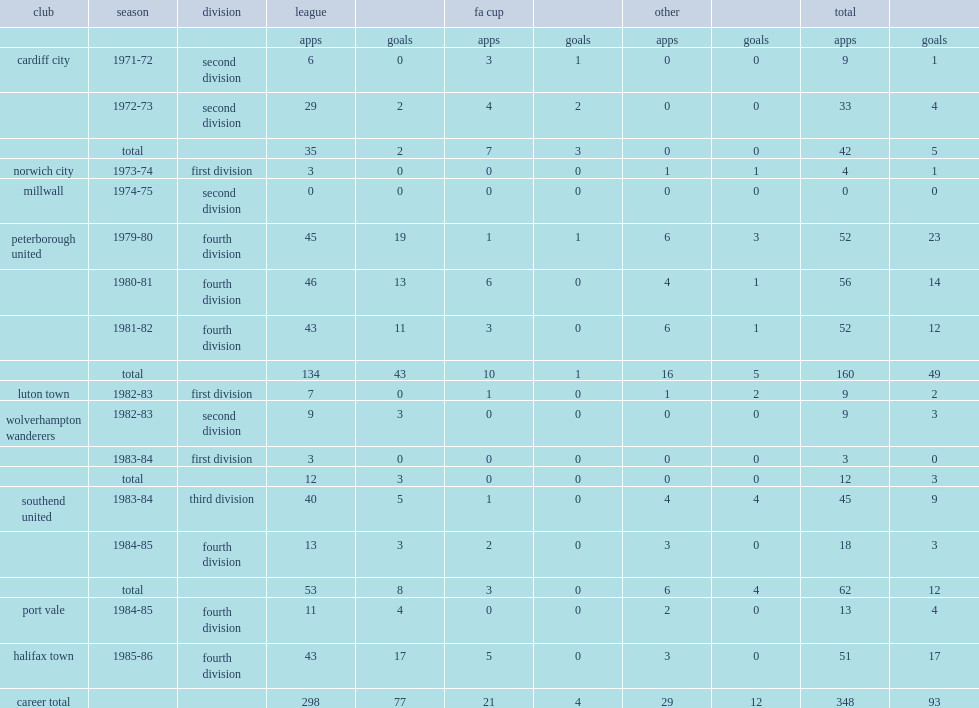Which club did billy kellock play for in 1973-74? Norwich city. Parse the table in full. {'header': ['club', 'season', 'division', 'league', '', 'fa cup', '', 'other', '', 'total', ''], 'rows': [['', '', '', 'apps', 'goals', 'apps', 'goals', 'apps', 'goals', 'apps', 'goals'], ['cardiff city', '1971-72', 'second division', '6', '0', '3', '1', '0', '0', '9', '1'], ['', '1972-73', 'second division', '29', '2', '4', '2', '0', '0', '33', '4'], ['', 'total', '', '35', '2', '7', '3', '0', '0', '42', '5'], ['norwich city', '1973-74', 'first division', '3', '0', '0', '0', '1', '1', '4', '1'], ['millwall', '1974-75', 'second division', '0', '0', '0', '0', '0', '0', '0', '0'], ['peterborough united', '1979-80', 'fourth division', '45', '19', '1', '1', '6', '3', '52', '23'], ['', '1980-81', 'fourth division', '46', '13', '6', '0', '4', '1', '56', '14'], ['', '1981-82', 'fourth division', '43', '11', '3', '0', '6', '1', '52', '12'], ['', 'total', '', '134', '43', '10', '1', '16', '5', '160', '49'], ['luton town', '1982-83', 'first division', '7', '0', '1', '0', '1', '2', '9', '2'], ['wolverhampton wanderers', '1982-83', 'second division', '9', '3', '0', '0', '0', '0', '9', '3'], ['', '1983-84', 'first division', '3', '0', '0', '0', '0', '0', '3', '0'], ['', 'total', '', '12', '3', '0', '0', '0', '0', '12', '3'], ['southend united', '1983-84', 'third division', '40', '5', '1', '0', '4', '4', '45', '9'], ['', '1984-85', 'fourth division', '13', '3', '2', '0', '3', '0', '18', '3'], ['', 'total', '', '53', '8', '3', '0', '6', '4', '62', '12'], ['port vale', '1984-85', 'fourth division', '11', '4', '0', '0', '2', '0', '13', '4'], ['halifax town', '1985-86', 'fourth division', '43', '17', '5', '0', '3', '0', '51', '17'], ['career total', '', '', '298', '77', '21', '4', '29', '12', '348', '93']]} 